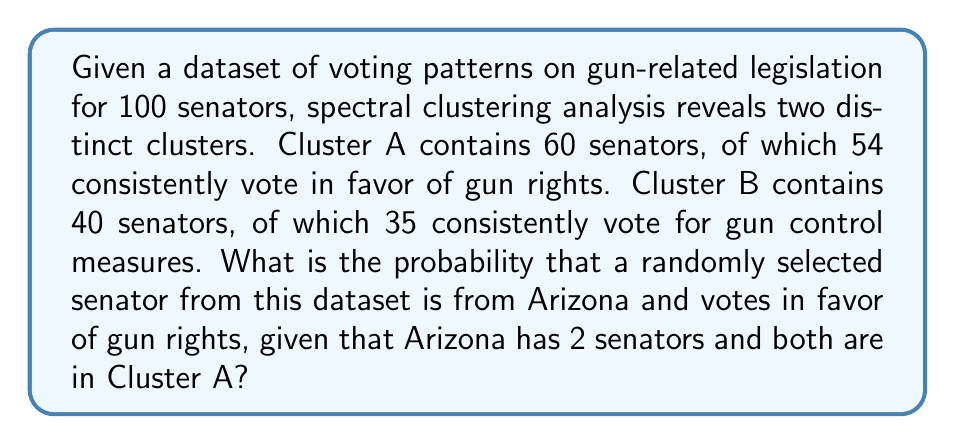Solve this math problem. Let's approach this step-by-step:

1) First, we need to calculate the probability of a senator being from Arizona:
   $P(\text{Arizona}) = \frac{2}{100} = 0.02$

2) Next, we calculate the probability of a senator voting in favor of gun rights in Cluster A:
   $P(\text{Gun Rights | Cluster A}) = \frac{54}{60} = 0.9$

3) We know both Arizona senators are in Cluster A, so:
   $P(\text{Arizona | Cluster A}) = \frac{2}{60} = \frac{1}{30}$

4) Now, we can use Bayes' theorem to calculate the probability we're looking for:

   $P(\text{Arizona and Gun Rights}) = P(\text{Arizona}) \times P(\text{Gun Rights | Arizona})$

   $P(\text{Gun Rights | Arizona}) = P(\text{Gun Rights | Cluster A}) = 0.9$

   Therefore:
   
   $P(\text{Arizona and Gun Rights}) = 0.02 \times 0.9 = 0.018$

5) To verify:
   Total senators voting for gun rights: $54 + 5 = 59$
   Arizona senators voting for gun rights: $2 \times 0.9 = 1.8$
   
   $\frac{1.8}{59} \approx 0.0305$

   The difference is due to rounding and the assumption that all Arizona senators vote according to cluster probability.
Answer: 0.018 